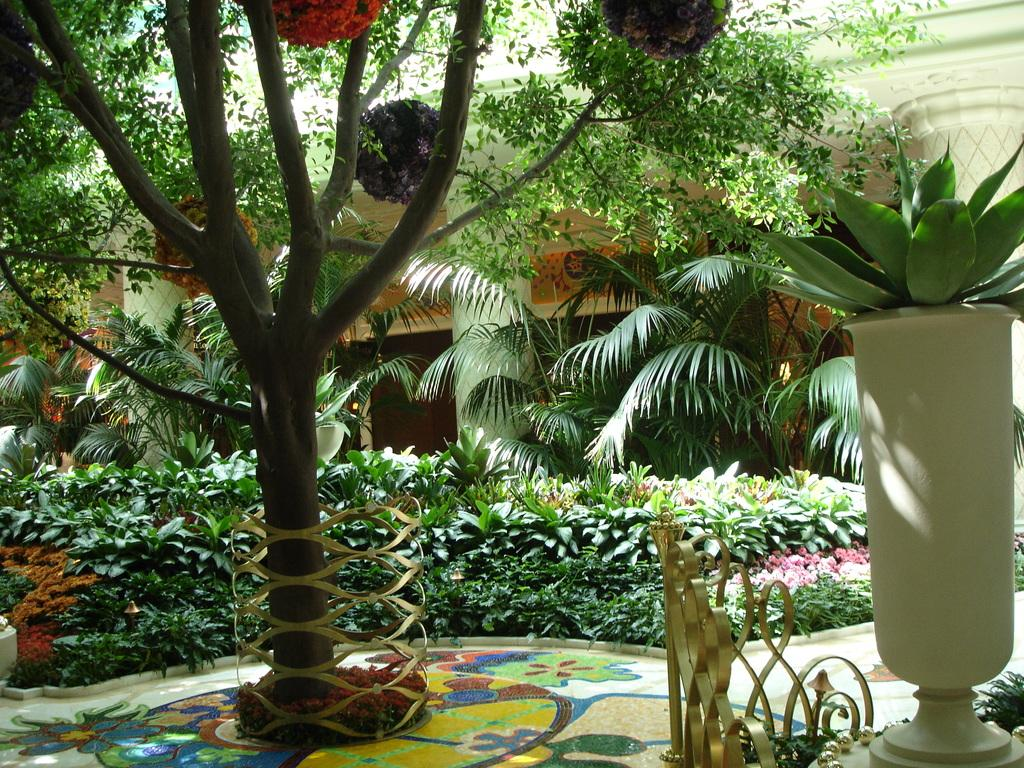What can be seen in the foreground of the image? In the foreground of the image, there are trees, plants, a flower pot, and flowers. Can you describe the background of the image? In the background of the image, there is a house. What additional detail can be observed at the bottom of the image? There is some painting at the bottom of the image. How many veins can be seen on the kitty in the image? There is no kitty present in the image, so it is not possible to determine the number of veins on a kitty. 